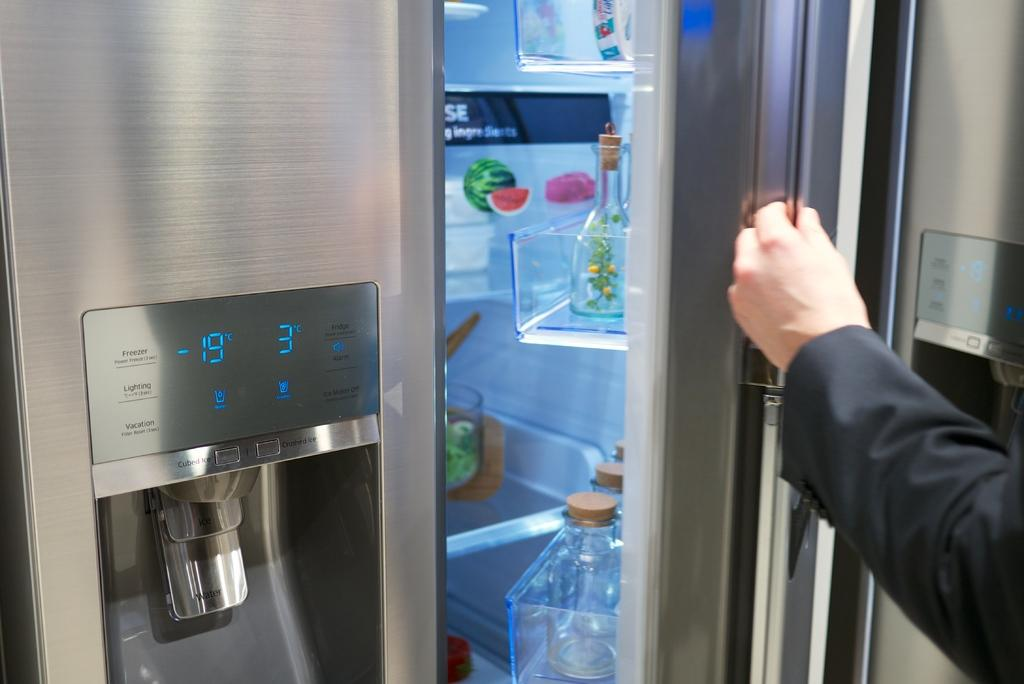<image>
Relay a brief, clear account of the picture shown. A stainless steel refrigerator has a digital displaying  -19 